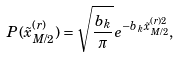<formula> <loc_0><loc_0><loc_500><loc_500>P ( \tilde { x } _ { M / 2 } ^ { ( r ) } ) = \sqrt { \frac { b _ { k } } { \pi } } e ^ { - b _ { k } \tilde { x } _ { M / 2 } ^ { ( r ) 2 } } ,</formula> 